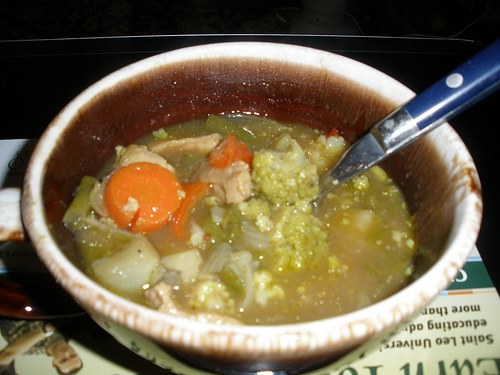Is there any soup in the photo? Yes, there is soup in the photo. You can see a bowl filled with it. 